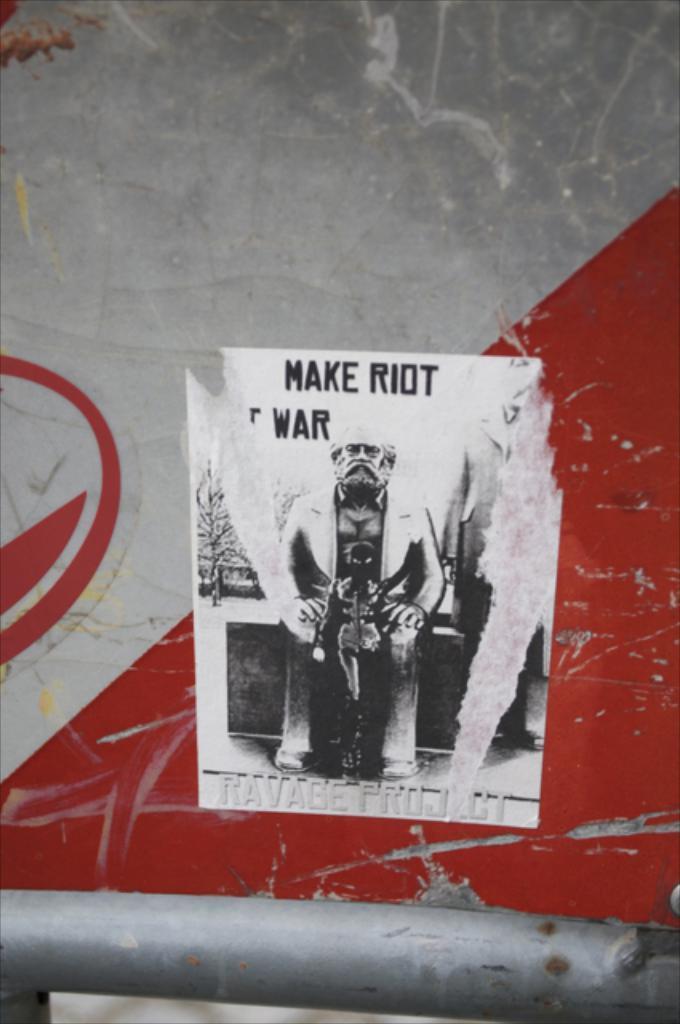Can you describe this image briefly? In the center of the image we can see poster to the wall. 